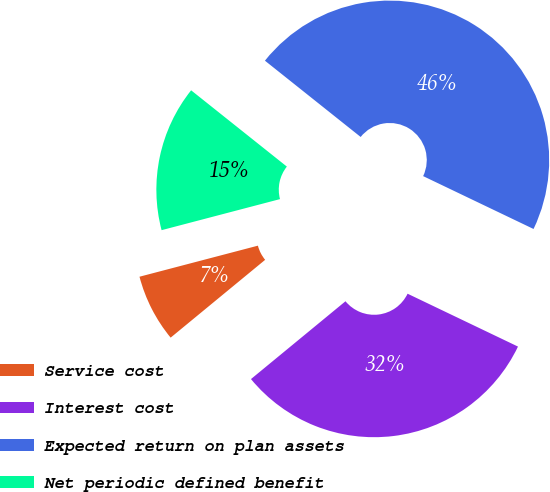Convert chart to OTSL. <chart><loc_0><loc_0><loc_500><loc_500><pie_chart><fcel>Service cost<fcel>Interest cost<fcel>Expected return on plan assets<fcel>Net periodic defined benefit<nl><fcel>6.88%<fcel>31.93%<fcel>46.4%<fcel>14.79%<nl></chart> 